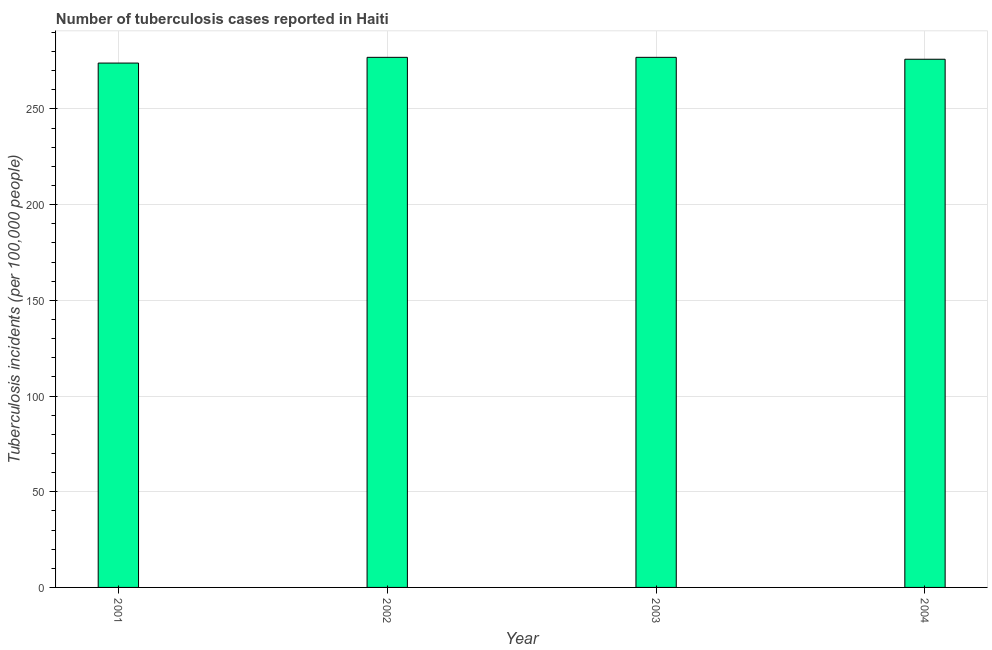What is the title of the graph?
Give a very brief answer. Number of tuberculosis cases reported in Haiti. What is the label or title of the Y-axis?
Offer a terse response. Tuberculosis incidents (per 100,0 people). What is the number of tuberculosis incidents in 2003?
Keep it short and to the point. 277. Across all years, what is the maximum number of tuberculosis incidents?
Make the answer very short. 277. Across all years, what is the minimum number of tuberculosis incidents?
Provide a short and direct response. 274. In which year was the number of tuberculosis incidents minimum?
Ensure brevity in your answer.  2001. What is the sum of the number of tuberculosis incidents?
Provide a succinct answer. 1104. What is the average number of tuberculosis incidents per year?
Make the answer very short. 276. What is the median number of tuberculosis incidents?
Offer a terse response. 276.5. Is the sum of the number of tuberculosis incidents in 2002 and 2003 greater than the maximum number of tuberculosis incidents across all years?
Ensure brevity in your answer.  Yes. In how many years, is the number of tuberculosis incidents greater than the average number of tuberculosis incidents taken over all years?
Ensure brevity in your answer.  2. What is the difference between two consecutive major ticks on the Y-axis?
Give a very brief answer. 50. What is the Tuberculosis incidents (per 100,000 people) of 2001?
Offer a terse response. 274. What is the Tuberculosis incidents (per 100,000 people) in 2002?
Your answer should be compact. 277. What is the Tuberculosis incidents (per 100,000 people) in 2003?
Provide a succinct answer. 277. What is the Tuberculosis incidents (per 100,000 people) of 2004?
Your answer should be very brief. 276. What is the difference between the Tuberculosis incidents (per 100,000 people) in 2001 and 2003?
Offer a terse response. -3. What is the difference between the Tuberculosis incidents (per 100,000 people) in 2001 and 2004?
Make the answer very short. -2. What is the difference between the Tuberculosis incidents (per 100,000 people) in 2002 and 2004?
Give a very brief answer. 1. What is the ratio of the Tuberculosis incidents (per 100,000 people) in 2002 to that in 2003?
Your response must be concise. 1. What is the ratio of the Tuberculosis incidents (per 100,000 people) in 2002 to that in 2004?
Provide a succinct answer. 1. What is the ratio of the Tuberculosis incidents (per 100,000 people) in 2003 to that in 2004?
Keep it short and to the point. 1. 